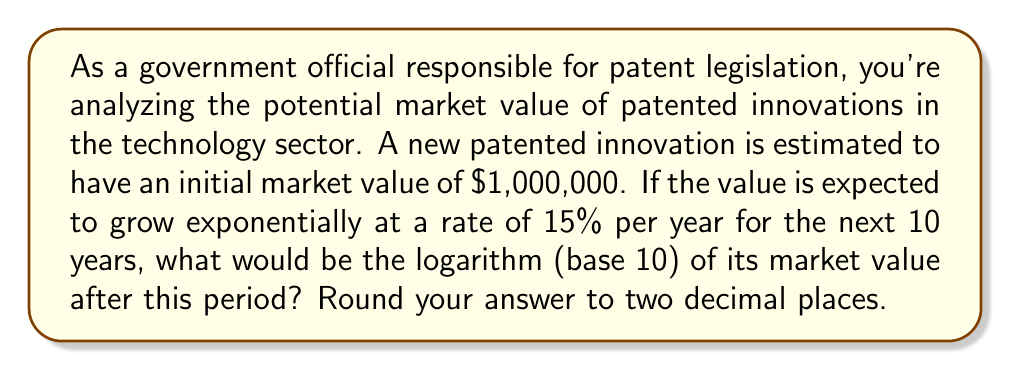Help me with this question. Let's approach this problem step-by-step:

1) The initial value is $1,000,000 and it grows at a rate of 15% per year.

2) To calculate the value after 10 years, we use the compound interest formula:
   $$ A = P(1 + r)^t $$
   Where:
   $A$ is the final amount
   $P$ is the principal (initial amount)
   $r$ is the annual growth rate
   $t$ is the time in years

3) Plugging in our values:
   $$ A = 1,000,000(1 + 0.15)^{10} $$

4) Let's calculate this:
   $$ A = 1,000,000(1.15)^{10} = 1,000,000(4.0456) = 4,045,600 $$

5) Now, we need to find the logarithm (base 10) of this value:
   $$ \log_{10}(4,045,600) $$

6) Using a calculator or logarithm tables:
   $$ \log_{10}(4,045,600) \approx 6.6069 $$

7) Rounding to two decimal places:
   $$ \log_{10}(4,045,600) \approx 6.61 $$

This logarithmic scale is useful in patent legislation as it allows for comparison of innovations with vastly different market values on a more manageable scale.
Answer: 6.61 